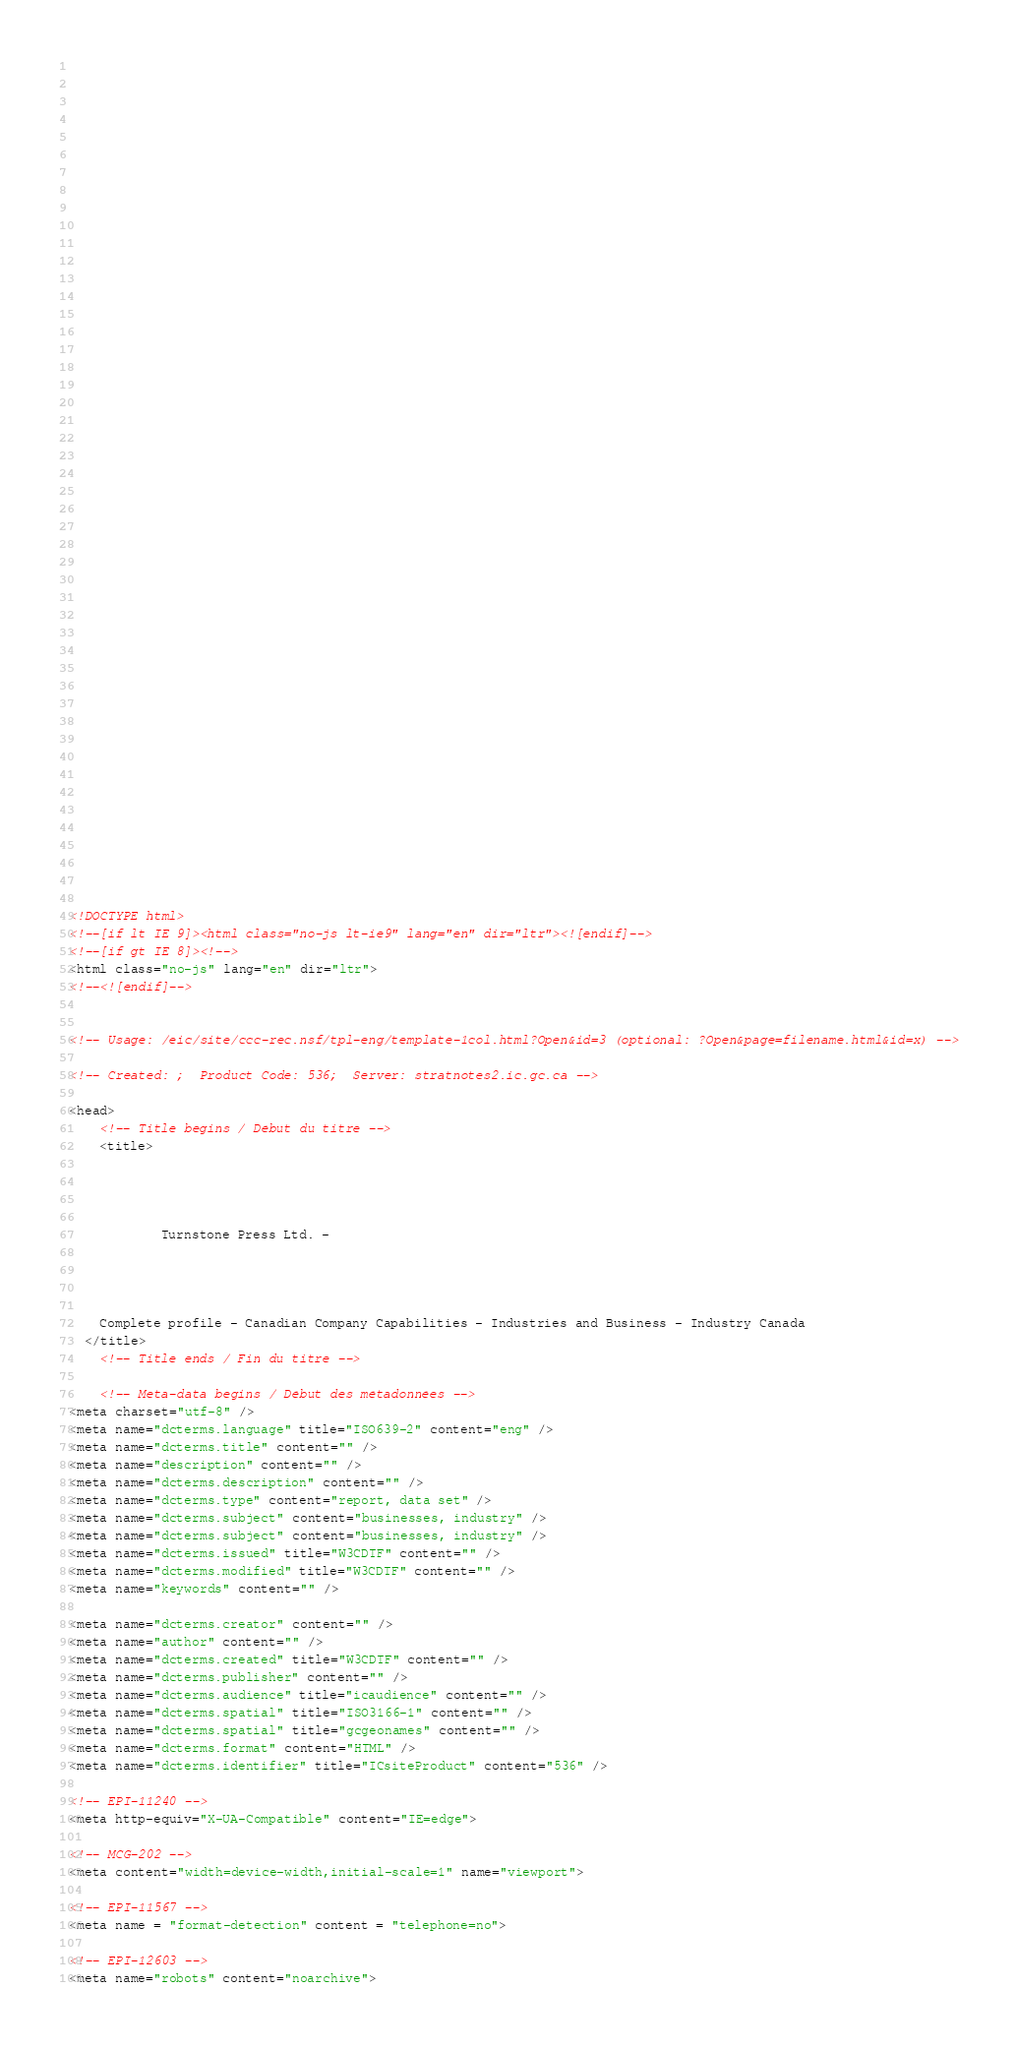<code> <loc_0><loc_0><loc_500><loc_500><_HTML_>


















	






  
  
  
  































	
	
	



<!DOCTYPE html>
<!--[if lt IE 9]><html class="no-js lt-ie9" lang="en" dir="ltr"><![endif]-->
<!--[if gt IE 8]><!-->
<html class="no-js" lang="en" dir="ltr">
<!--<![endif]-->


<!-- Usage: /eic/site/ccc-rec.nsf/tpl-eng/template-1col.html?Open&id=3 (optional: ?Open&page=filename.html&id=x) -->

<!-- Created: ;  Product Code: 536;  Server: stratnotes2.ic.gc.ca -->

<head>
	<!-- Title begins / Début du titre -->
	<title>
    
            
        
          
            Turnstone Press Ltd. -
          
        
      
    
    Complete profile - Canadian Company Capabilities - Industries and Business - Industry Canada
  </title>
	<!-- Title ends / Fin du titre -->
 
	<!-- Meta-data begins / Début des métadonnées -->
<meta charset="utf-8" />
<meta name="dcterms.language" title="ISO639-2" content="eng" />
<meta name="dcterms.title" content="" />
<meta name="description" content="" />
<meta name="dcterms.description" content="" />
<meta name="dcterms.type" content="report, data set" />
<meta name="dcterms.subject" content="businesses, industry" />
<meta name="dcterms.subject" content="businesses, industry" />
<meta name="dcterms.issued" title="W3CDTF" content="" />
<meta name="dcterms.modified" title="W3CDTF" content="" />
<meta name="keywords" content="" />

<meta name="dcterms.creator" content="" />
<meta name="author" content="" />
<meta name="dcterms.created" title="W3CDTF" content="" />
<meta name="dcterms.publisher" content="" />
<meta name="dcterms.audience" title="icaudience" content="" />
<meta name="dcterms.spatial" title="ISO3166-1" content="" />
<meta name="dcterms.spatial" title="gcgeonames" content="" />
<meta name="dcterms.format" content="HTML" />
<meta name="dcterms.identifier" title="ICsiteProduct" content="536" />

<!-- EPI-11240 -->
<meta http-equiv="X-UA-Compatible" content="IE=edge">

<!-- MCG-202 -->
<meta content="width=device-width,initial-scale=1" name="viewport">

<!-- EPI-11567 -->
<meta name = "format-detection" content = "telephone=no">

<!-- EPI-12603 -->
<meta name="robots" content="noarchive">
</code> 